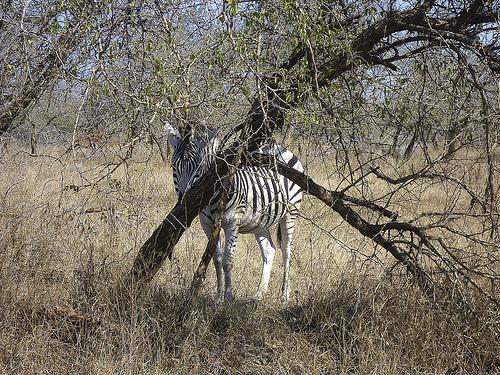How many zebras can be seen in the photo?
Give a very brief answer. 1. How many legs does the zebra have?
Give a very brief answer. 4. 